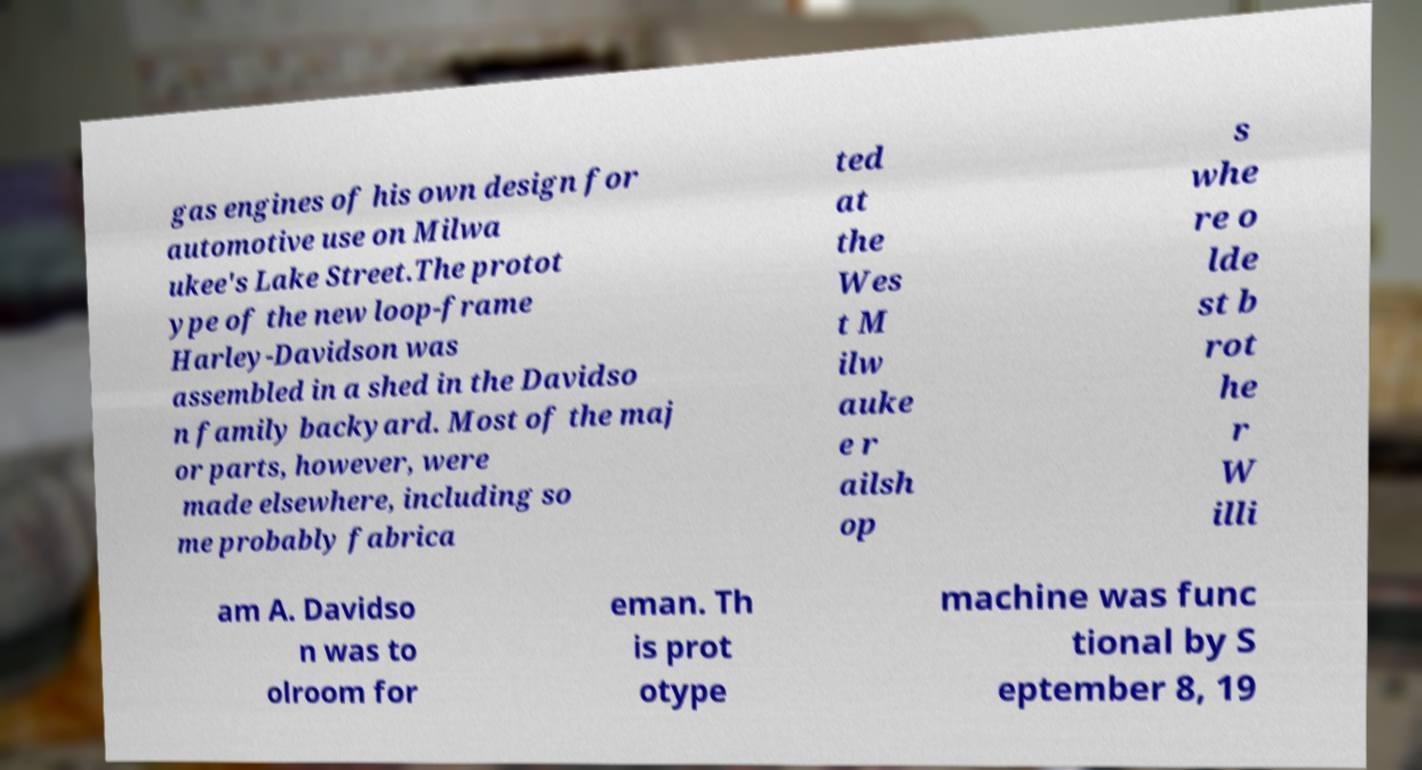I need the written content from this picture converted into text. Can you do that? gas engines of his own design for automotive use on Milwa ukee's Lake Street.The protot ype of the new loop-frame Harley-Davidson was assembled in a shed in the Davidso n family backyard. Most of the maj or parts, however, were made elsewhere, including so me probably fabrica ted at the Wes t M ilw auke e r ailsh op s whe re o lde st b rot he r W illi am A. Davidso n was to olroom for eman. Th is prot otype machine was func tional by S eptember 8, 19 